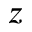Convert formula to latex. <formula><loc_0><loc_0><loc_500><loc_500>z</formula> 